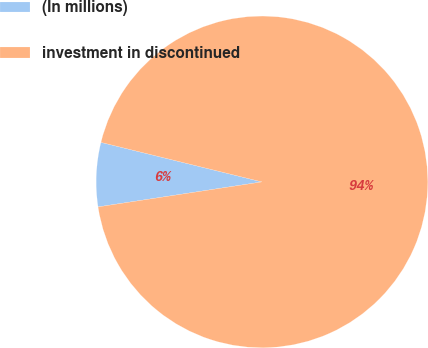<chart> <loc_0><loc_0><loc_500><loc_500><pie_chart><fcel>(In millions)<fcel>investment in discontinued<nl><fcel>6.24%<fcel>93.76%<nl></chart> 